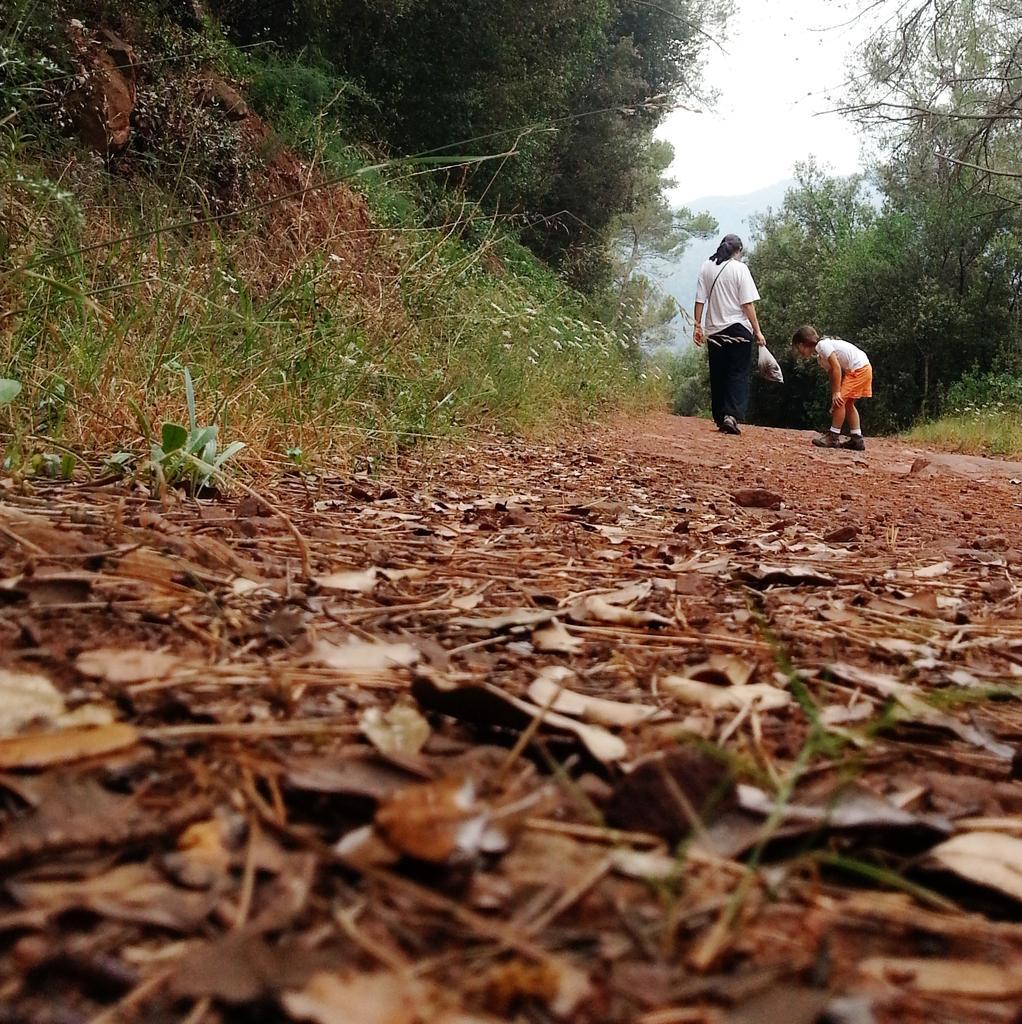Could you give a brief overview of what you see in this image? This image is taken outdoors. At the bottom of the image there is a ground with many dry leaves on it. At the top of the image there are many trees and plants on the ground and there is the sky. On the right side of the image a man is walking on the ground and a kid is standing on the ground. 